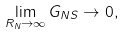<formula> <loc_0><loc_0><loc_500><loc_500>\lim _ { R _ { N } \to \infty } G _ { N S } \to 0 ,</formula> 